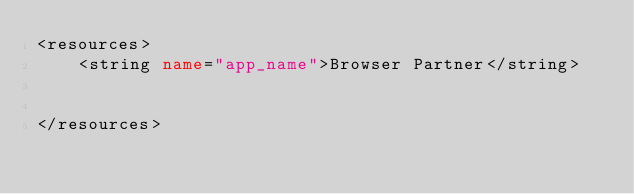<code> <loc_0><loc_0><loc_500><loc_500><_XML_><resources>
    <string name="app_name">Browser Partner</string>


</resources>
</code> 